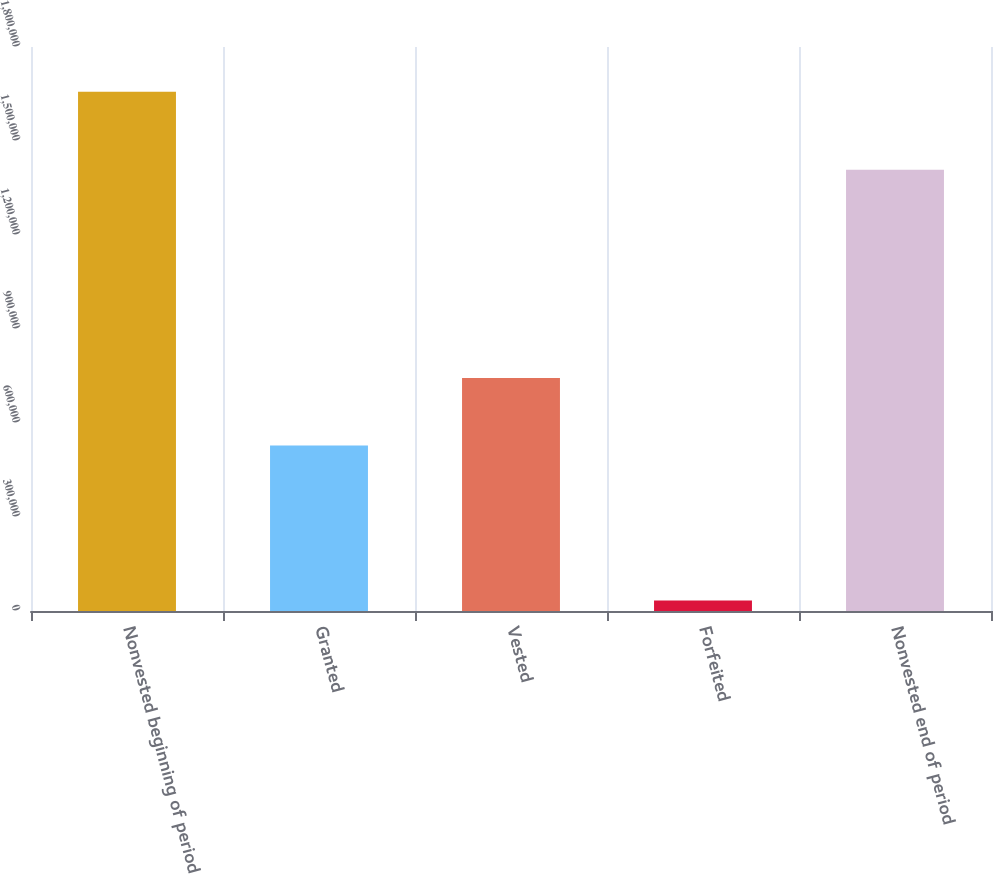Convert chart. <chart><loc_0><loc_0><loc_500><loc_500><bar_chart><fcel>Nonvested beginning of period<fcel>Granted<fcel>Vested<fcel>Forfeited<fcel>Nonvested end of period<nl><fcel>1.65683e+06<fcel>528580<fcel>743968<fcel>33400<fcel>1.40804e+06<nl></chart> 